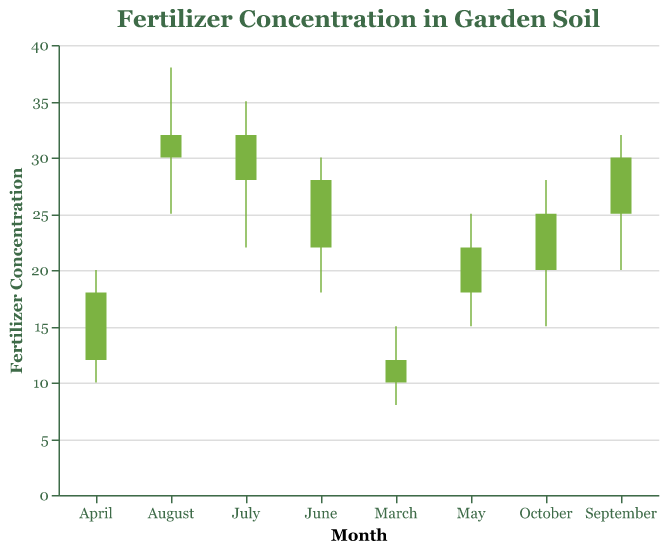Which month had the highest peak fertilizer concentration? The highest peak in the chart occurs in August, with a value of 38. This is clearly seen on the “Highest” bar for August.
Answer: August What is the difference between the highest and lowest fertilizer concentrations in July? For July, the highest concentration is 35 and the lowest is 22. Subtract the lowest from the highest value: 35 - 22.
Answer: 13 How did the fertilizer concentration change from March to April? In March, the final reading was 12, and in April, the initial reading was 12 and the final reading was 18. This shows an increase from 12 to 18.
Answer: Increased by 6 During which month was the initial fertilizer concentration the highest? The highest initial concentration can be found by looking for the tallest initial bar, which occurs in August with a value of 32.
Answer: August How much did the fertilizer concentration drop from its highest point in June to its lowest point in October? The highest reading in June is 30, and the lowest reading in October is 15. The drop is 30 - 15.
Answer: 15 Which month had the greatest variability in fertilizer concentration? Variability is determined by the range between the highest and lowest values. July has the greatest range: 35 (highest) - 22 (lowest) = 13.
Answer: July What is the average final fertilizer concentration over the growing cycle? Add the final concentrations from all months: 12 + 18 + 22 + 28 + 32 + 30 + 25 + 20, then divide by the number of months: 8. The sum is 187, and the average is 187 / 8.
Answer: 23.375 Which month experienced the largest increase in fertilizer concentration from initial to highest reading? Compare the difference between initial and highest values for each month. June has the largest increase: 30 (highest) - 22 (initial) = 8.
Answer: June By how much did the final fertilizer concentration decrease from September to October? The final concentration in September is 25 and in October, it is 20. Subtract October's value from September's: 25 - 20.
Answer: 5 